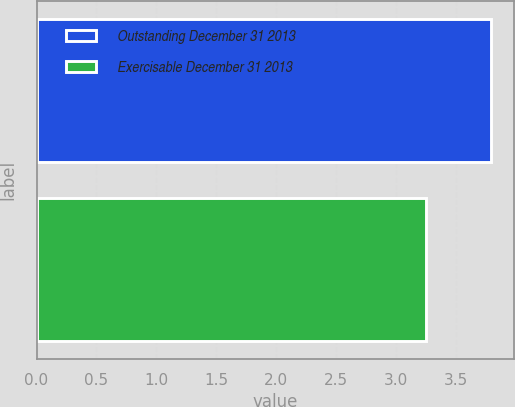<chart> <loc_0><loc_0><loc_500><loc_500><bar_chart><fcel>Outstanding December 31 2013<fcel>Exercisable December 31 2013<nl><fcel>3.79<fcel>3.25<nl></chart> 